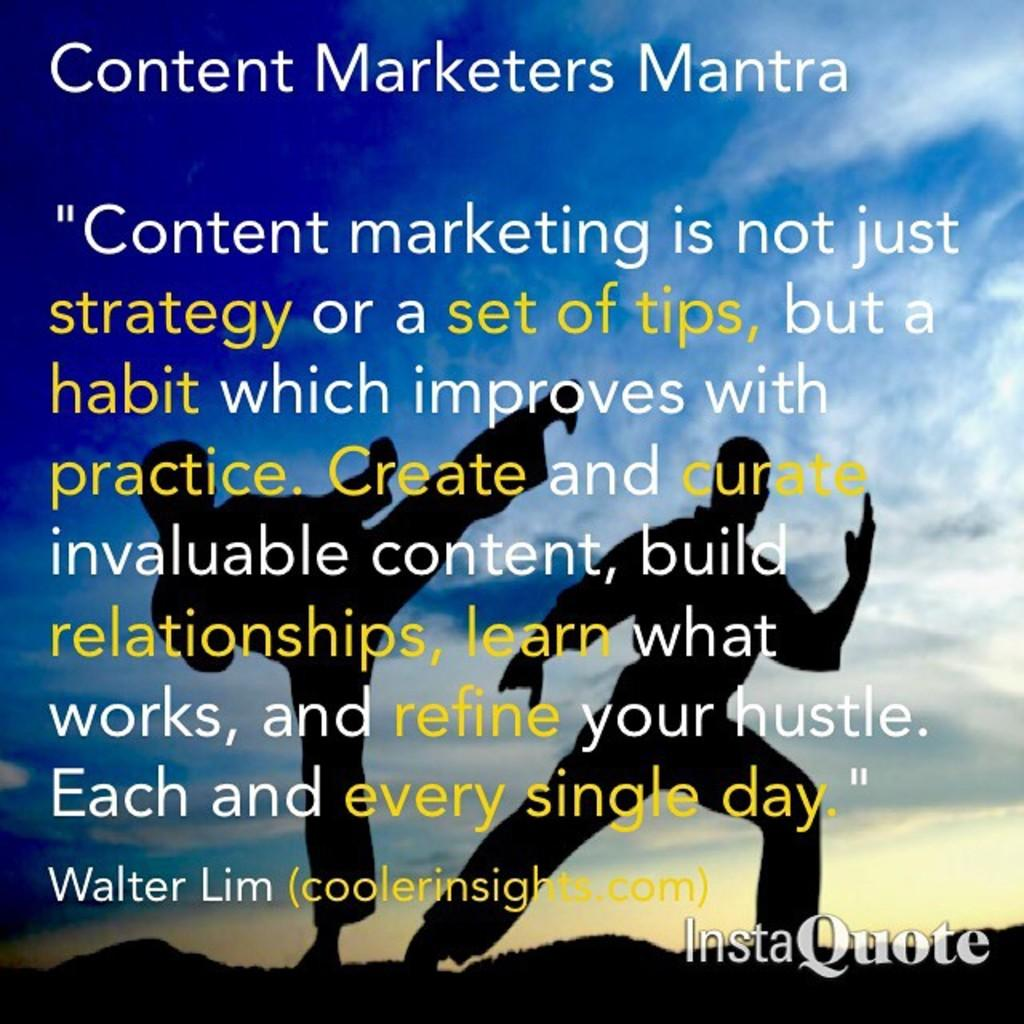<image>
Describe the image concisely. a long quote with instaquote on the bottom 